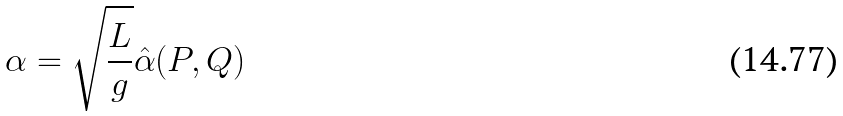Convert formula to latex. <formula><loc_0><loc_0><loc_500><loc_500>\alpha = \sqrt { \frac { L } { g } } \hat { \alpha } ( P , Q )</formula> 